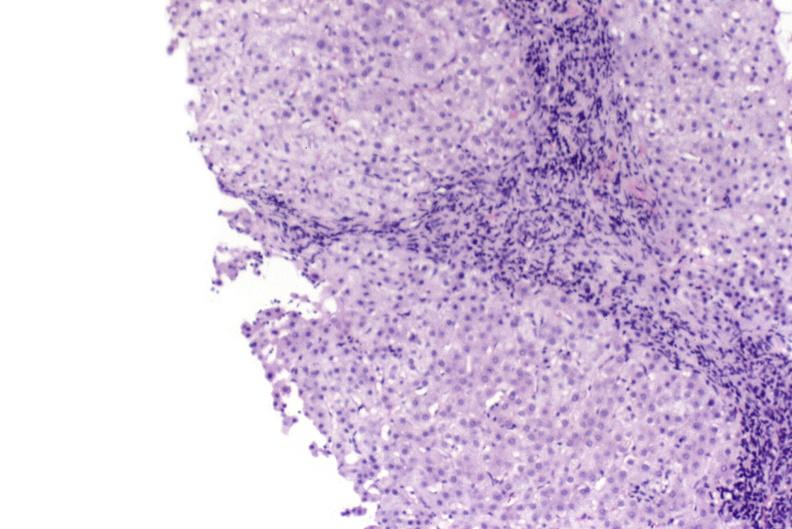s marfans syndrome present?
Answer the question using a single word or phrase. No 